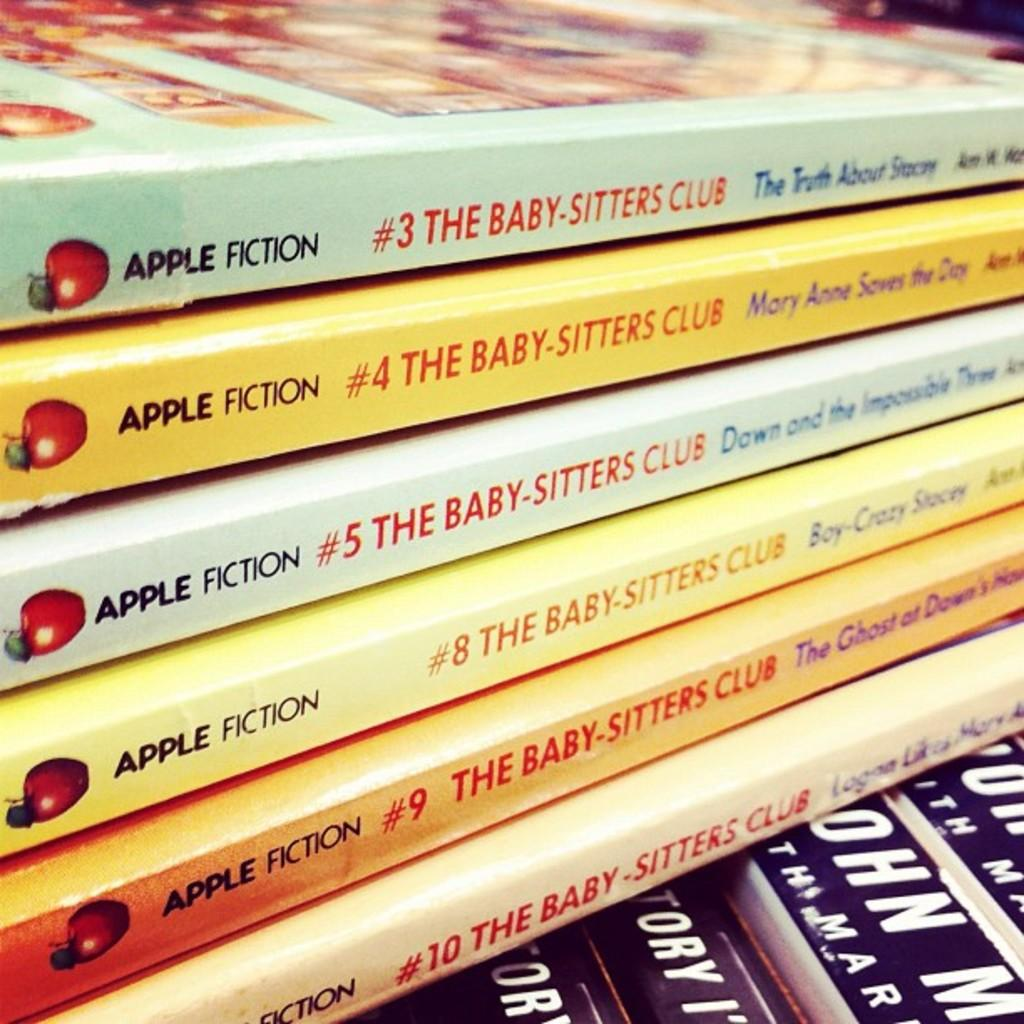<image>
Write a terse but informative summary of the picture. A stack of The Baby-Sitters Club books are multicolored. 